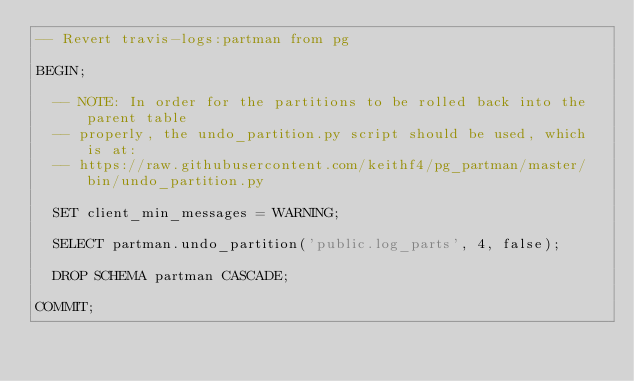<code> <loc_0><loc_0><loc_500><loc_500><_SQL_>-- Revert travis-logs:partman from pg

BEGIN;

  -- NOTE: In order for the partitions to be rolled back into the parent table
  -- properly, the undo_partition.py script should be used, which is at:
  -- https://raw.githubusercontent.com/keithf4/pg_partman/master/bin/undo_partition.py

  SET client_min_messages = WARNING;

  SELECT partman.undo_partition('public.log_parts', 4, false);

  DROP SCHEMA partman CASCADE;

COMMIT;
</code> 